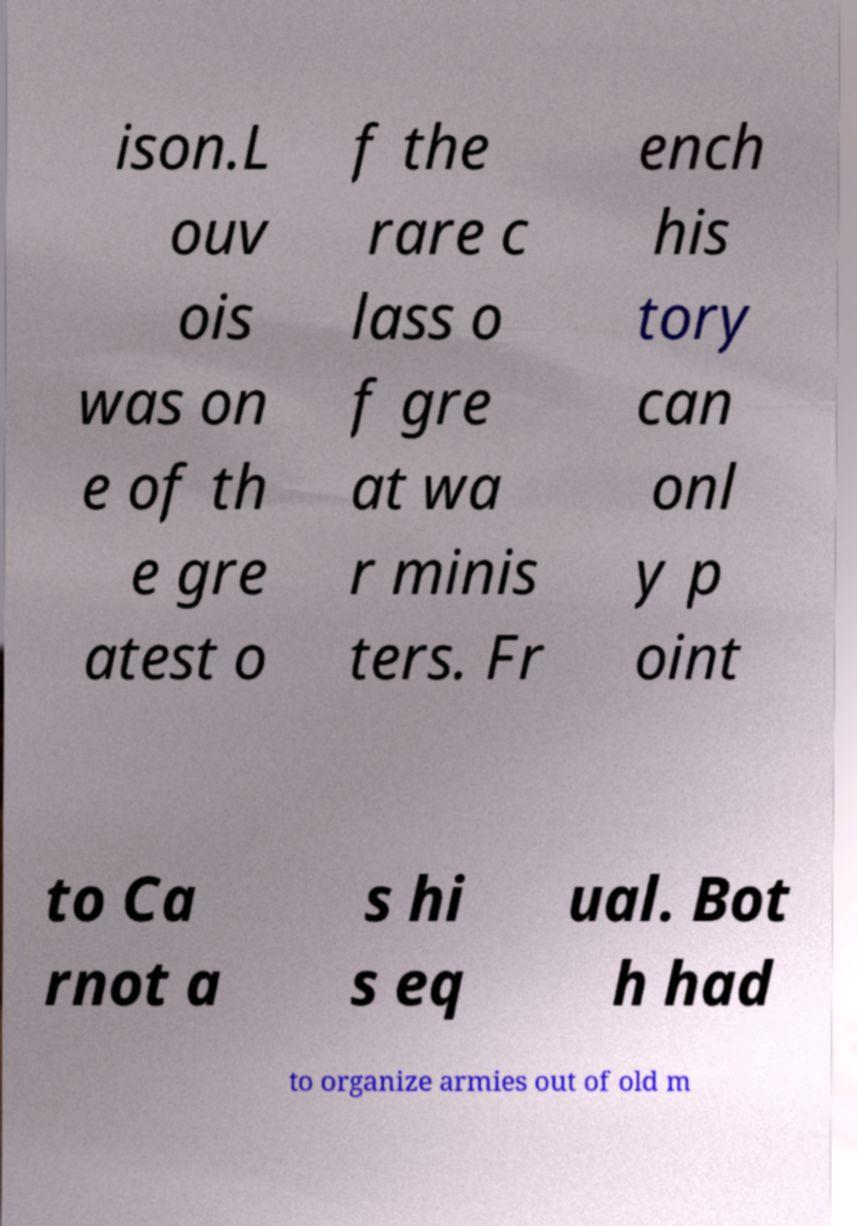Can you accurately transcribe the text from the provided image for me? ison.L ouv ois was on e of th e gre atest o f the rare c lass o f gre at wa r minis ters. Fr ench his tory can onl y p oint to Ca rnot a s hi s eq ual. Bot h had to organize armies out of old m 